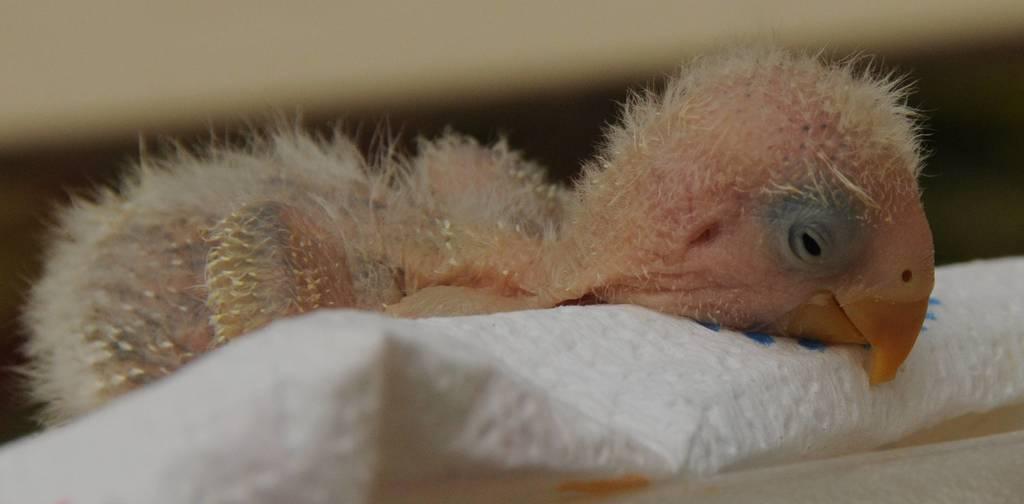Please provide a concise description of this image. In this image we can see a bird on the white surface. 